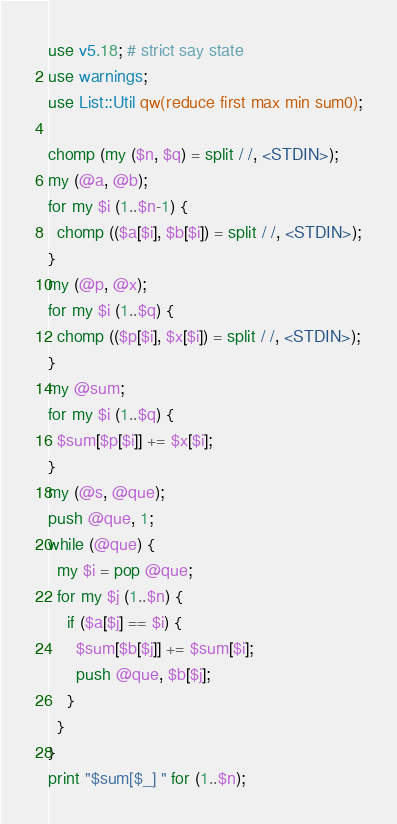Convert code to text. <code><loc_0><loc_0><loc_500><loc_500><_Perl_>use v5.18; # strict say state
use warnings;
use List::Util qw(reduce first max min sum0);

chomp (my ($n, $q) = split / /, <STDIN>);
my (@a, @b);
for my $i (1..$n-1) {
  chomp (($a[$i], $b[$i]) = split / /, <STDIN>);
}
my (@p, @x);
for my $i (1..$q) {
  chomp (($p[$i], $x[$i]) = split / /, <STDIN>);
}
my @sum;
for my $i (1..$q) {
  $sum[$p[$i]] += $x[$i];
}
my (@s, @que);
push @que, 1;
while (@que) {
  my $i = pop @que;
  for my $j (1..$n) {
    if ($a[$j] == $i) {
      $sum[$b[$j]] += $sum[$i];
      push @que, $b[$j];
    }
  }
}
print "$sum[$_] " for (1..$n);</code> 